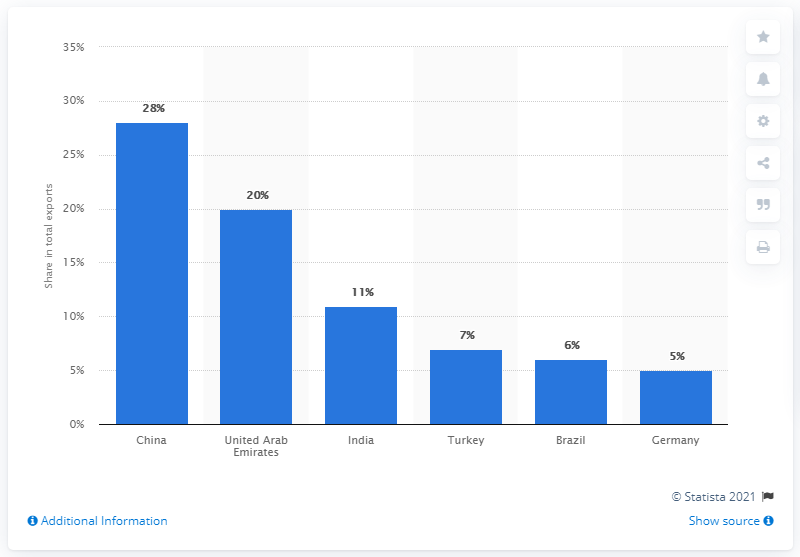Highlight a few significant elements in this photo. In 2019, Iran's main import partner was China. In 2019, China was Iran's main import partner. 